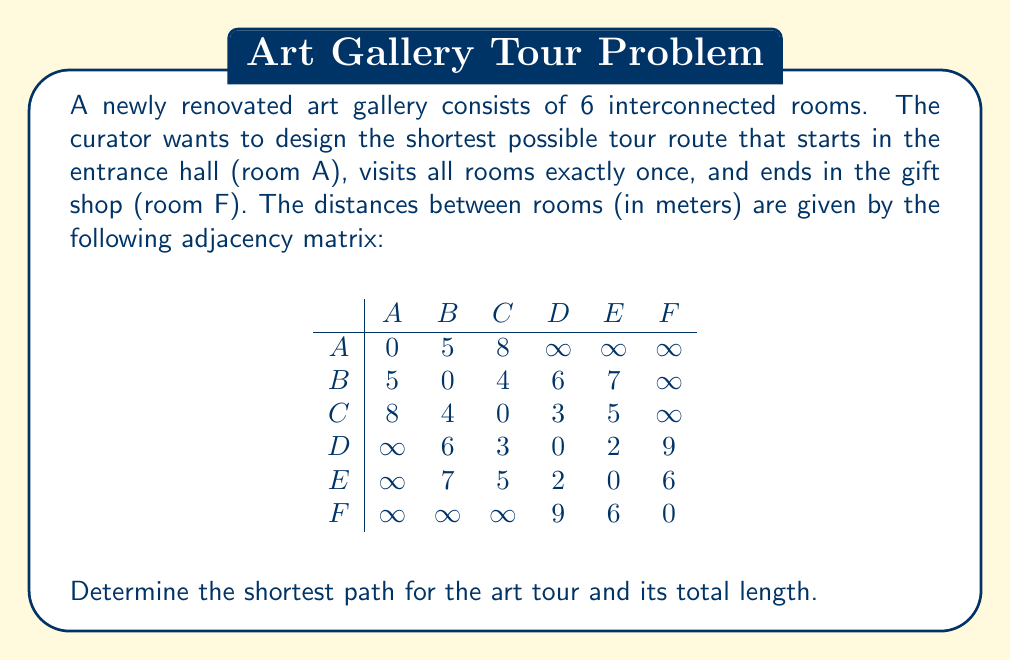Provide a solution to this math problem. To solve this problem, we need to find the shortest Hamiltonian path from A to F in the given graph. Since the number of rooms is small, we can use a brute-force approach to examine all possible paths.

1. List all possible paths from A to F that visit each room exactly once:
   - A -> B -> C -> D -> E -> F
   - A -> B -> C -> E -> D -> F
   - A -> B -> D -> C -> E -> F
   - A -> B -> D -> E -> C -> F
   - A -> B -> E -> C -> D -> F
   - A -> B -> E -> D -> C -> F
   - A -> C -> B -> D -> E -> F
   - A -> C -> B -> E -> D -> F
   - A -> C -> D -> B -> E -> F
   - A -> C -> D -> E -> B -> F
   - A -> C -> E -> B -> D -> F
   - A -> C -> E -> D -> B -> F

2. Calculate the length of each path using the given adjacency matrix:
   - A -> B -> C -> D -> E -> F = 5 + 4 + 3 + 2 + 6 = 20
   - A -> B -> C -> E -> D -> F = 5 + 4 + 5 + 2 + 9 = 25
   - A -> B -> D -> C -> E -> F = 5 + 6 + 3 + 5 + 6 = 25
   - A -> B -> D -> E -> C -> F = 5 + 6 + 2 + 5 + ∞ = ∞ (invalid)
   - A -> B -> E -> C -> D -> F = 5 + 7 + 5 + 3 + 9 = 29
   - A -> B -> E -> D -> C -> F = 5 + 7 + 2 + 3 + ∞ = ∞ (invalid)
   - A -> C -> B -> D -> E -> F = 8 + 4 + 6 + 2 + 6 = 26
   - A -> C -> B -> E -> D -> F = 8 + 4 + 7 + 2 + 9 = 30
   - A -> C -> D -> B -> E -> F = 8 + 3 + 6 + 7 + 6 = 30
   - A -> C -> D -> E -> B -> F = 8 + 3 + 2 + 7 + ∞ = ∞ (invalid)
   - A -> C -> E -> B -> D -> F = 8 + 5 + 7 + 6 + 9 = 35
   - A -> C -> E -> D -> B -> F = 8 + 5 + 2 + 6 + ∞ = ∞ (invalid)

3. Identify the shortest valid path:
   The shortest path is A -> B -> C -> D -> E -> F, with a total length of 20 meters.
Answer: The shortest path for the art tour is A -> B -> C -> D -> E -> F, with a total length of 20 meters. 